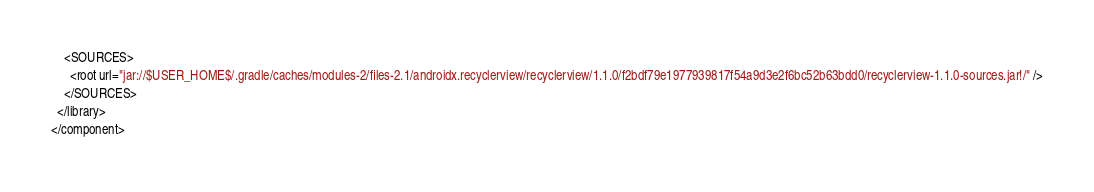Convert code to text. <code><loc_0><loc_0><loc_500><loc_500><_XML_>    <SOURCES>
      <root url="jar://$USER_HOME$/.gradle/caches/modules-2/files-2.1/androidx.recyclerview/recyclerview/1.1.0/f2bdf79e1977939817f54a9d3e2f6bc52b63bdd0/recyclerview-1.1.0-sources.jar!/" />
    </SOURCES>
  </library>
</component></code> 